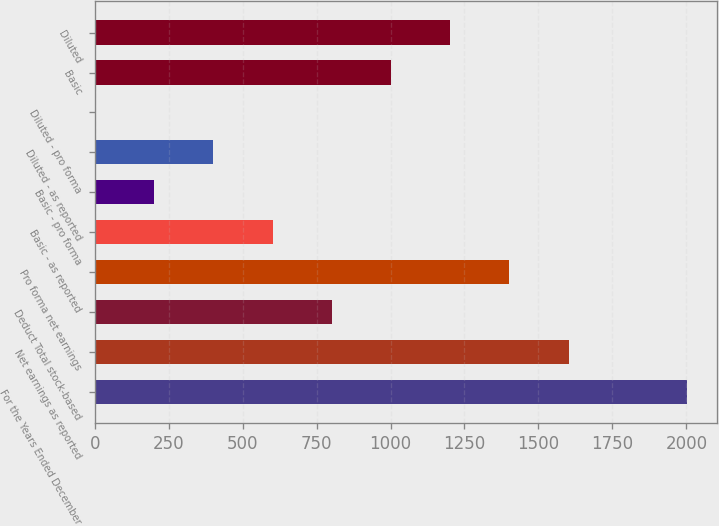Convert chart to OTSL. <chart><loc_0><loc_0><loc_500><loc_500><bar_chart><fcel>For the Years Ended December<fcel>Net earnings as reported<fcel>Deduct Total stock-based<fcel>Pro forma net earnings<fcel>Basic - as reported<fcel>Basic - pro forma<fcel>Diluted - as reported<fcel>Diluted - pro forma<fcel>Basic<fcel>Diluted<nl><fcel>2002<fcel>1601.88<fcel>801.57<fcel>1401.8<fcel>601.49<fcel>201.33<fcel>401.41<fcel>1.25<fcel>1001.65<fcel>1201.72<nl></chart> 